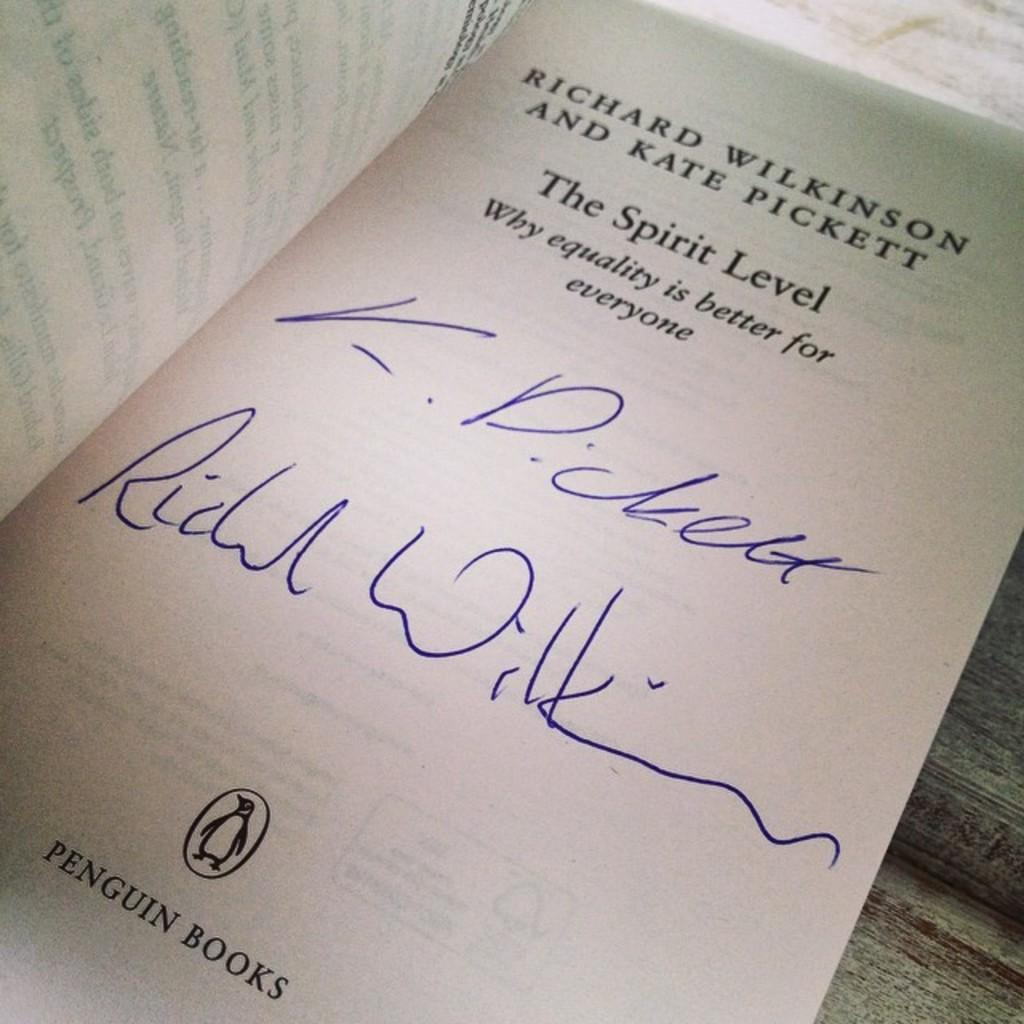What object can be seen in the image? There is a book in the image. What is written on the book? The book has text written on it. What type of engine is depicted on the book in the image? There is no engine depicted on the book in the image; it only has text written on it. 